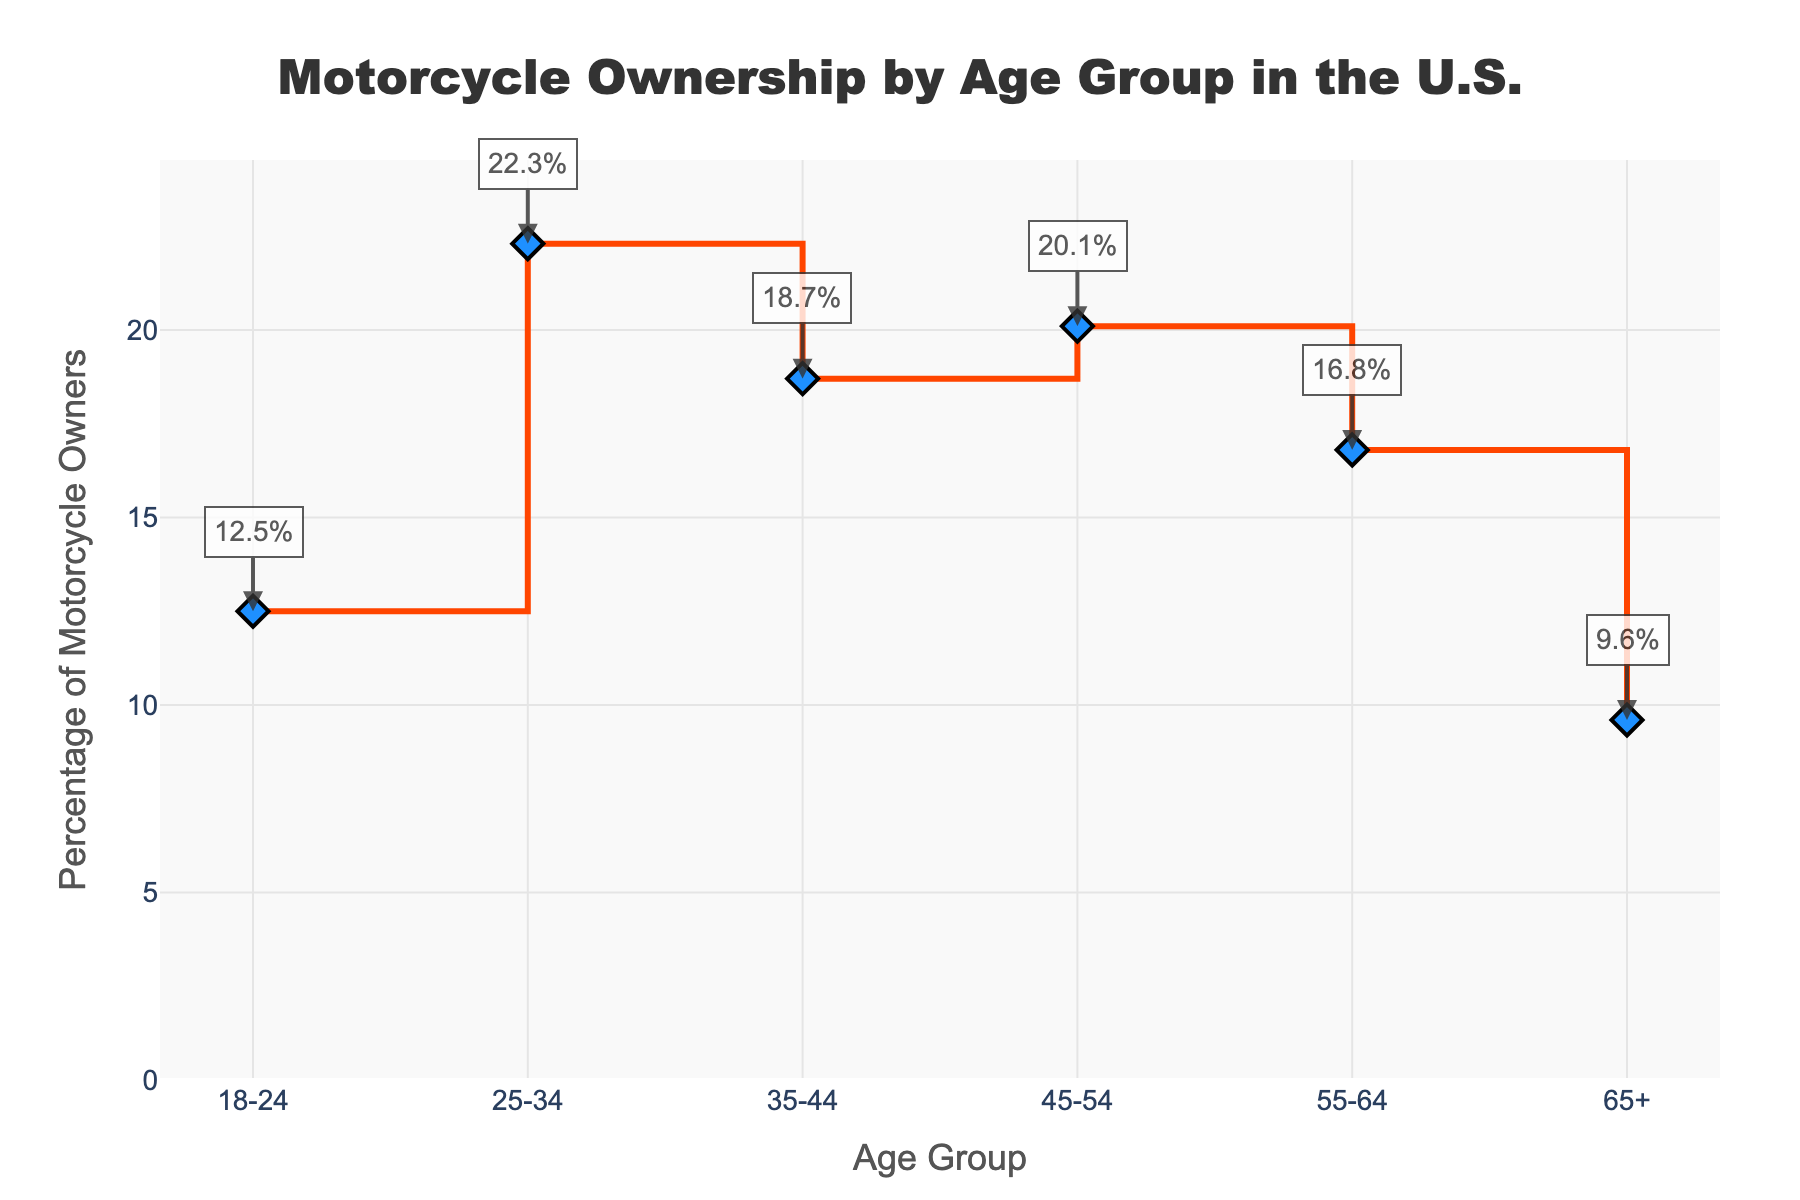What is the title of the figure? The title is located at the top of the figure, centered and prominent. It reads "Motorcycle Ownership by Age Group in the U.S."
Answer: Motorcycle Ownership by Age Group in the U.S What age group has the highest percentage of motorcycle owners? By examining the y-axis values and their corresponding age groups, the peak value on the plot is approximately 22.3% for the age group 25-34.
Answer: 25-34 How does the percentage of motorcycle owners change from the 18-24 age group to the 25-34 age group? By looking at the plot, the percentage for the 18-24 group is 12.5%, and it increases to 22.3% for the 25-34 group. The change is an increase.
Answer: Increases What is the difference in motorcycle ownership percentage between the 35-44 and 55-64 age groups? The figure shows that the 35-44 age group has 18.7% and the 55-64 age group has 16.8%. Subtracting these gives 18.7 - 16.8 = 1.9%.
Answer: 1.9% Which age group shows a declining trend in motorcycle ownership when compared to the previous age group? Examining the plot sequentially, the percentage decreases for the age groups from 25-34 to 35-44, and from 45-54 to 55-64, and then again from 55-64 to 65+. Therefore, 35-44, 55-64, and 65+ show a declining trend from the prior group.
Answer: 35-44, 55-64, and 65+ What percentage of the 45-54 age group owns motorcycles? By looking at the specific data point on the figure corresponding to the 45-54 age group, it shows 20.1%.
Answer: 20.1% What is the average percentage of motorcycle ownership across all age groups? The percentages are 12.5, 22.3, 18.7, 20.1, 16.8, and 9.6. Sum these values to get 100.0, then divide by the number of data points (6), so the average is 100.0 / 6 = 16.67%.
Answer: 16.67% What is the pattern of motorcycle ownership for those aged 65 and older? The percentage for the 65+ group is the lowest among all age groups at 9.6%, highlighting a steep decline in ownership as individuals age.
Answer: 9.6% How does motorcycle ownership in the 55-64 age group compare to the 18-24 age group? The percentage for the 55-64 age group (16.8%) is higher than that for the 18-24 age group (12.5%). This indicates more motorcycle ownership among 55-64 year-olds compared to 18-24 year-olds.
Answer: Higher 